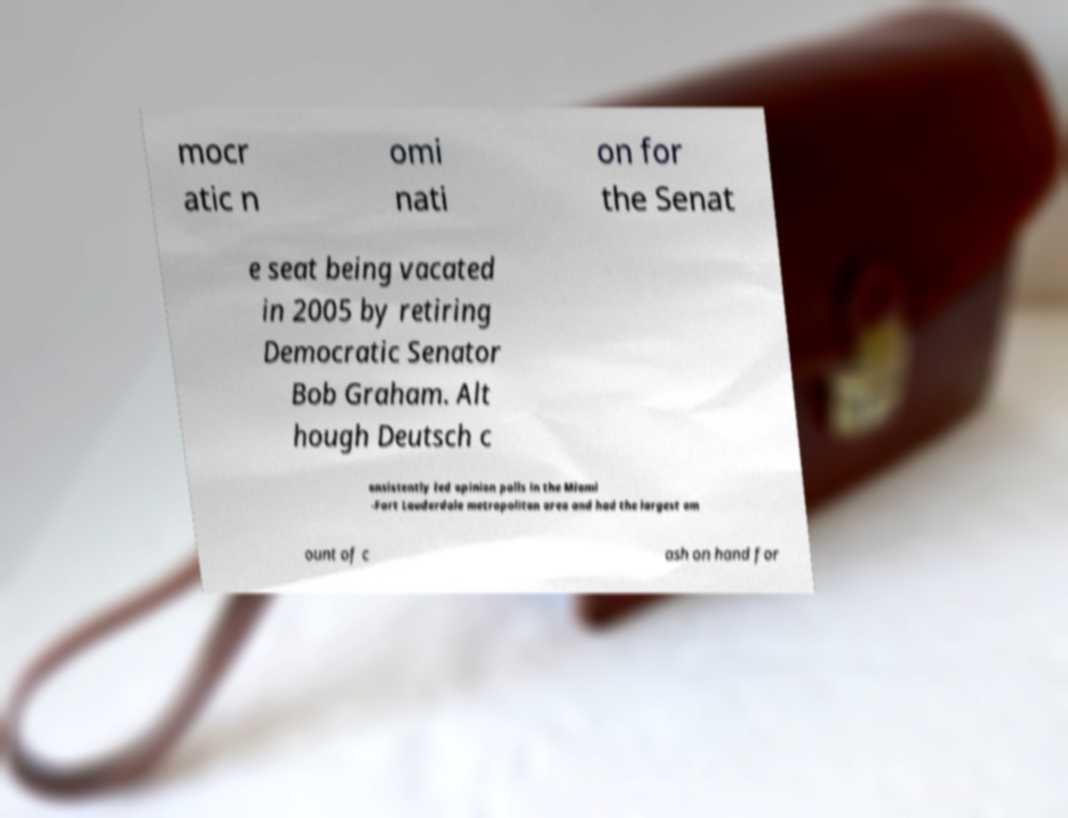Please identify and transcribe the text found in this image. mocr atic n omi nati on for the Senat e seat being vacated in 2005 by retiring Democratic Senator Bob Graham. Alt hough Deutsch c onsistently led opinion polls in the Miami -Fort Lauderdale metropolitan area and had the largest am ount of c ash on hand for 